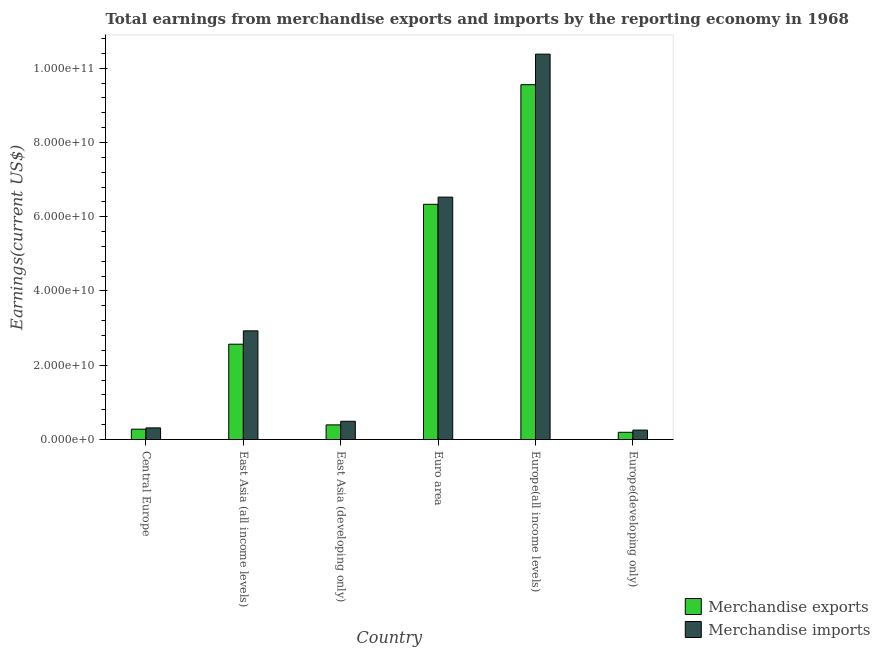How many different coloured bars are there?
Your answer should be compact. 2. Are the number of bars per tick equal to the number of legend labels?
Offer a terse response. Yes. Are the number of bars on each tick of the X-axis equal?
Your answer should be compact. Yes. How many bars are there on the 5th tick from the right?
Ensure brevity in your answer.  2. What is the label of the 1st group of bars from the left?
Ensure brevity in your answer.  Central Europe. What is the earnings from merchandise imports in Europe(all income levels)?
Provide a succinct answer. 1.04e+11. Across all countries, what is the maximum earnings from merchandise exports?
Provide a succinct answer. 9.56e+1. Across all countries, what is the minimum earnings from merchandise imports?
Offer a terse response. 2.54e+09. In which country was the earnings from merchandise imports maximum?
Provide a short and direct response. Europe(all income levels). In which country was the earnings from merchandise imports minimum?
Your answer should be compact. Europe(developing only). What is the total earnings from merchandise exports in the graph?
Your response must be concise. 1.93e+11. What is the difference between the earnings from merchandise exports in Central Europe and that in Europe(all income levels)?
Offer a very short reply. -9.28e+1. What is the difference between the earnings from merchandise imports in East Asia (all income levels) and the earnings from merchandise exports in Central Europe?
Make the answer very short. 2.65e+1. What is the average earnings from merchandise imports per country?
Your answer should be compact. 3.48e+1. What is the difference between the earnings from merchandise exports and earnings from merchandise imports in Central Europe?
Your response must be concise. -3.47e+08. In how many countries, is the earnings from merchandise imports greater than 4000000000 US$?
Provide a succinct answer. 4. What is the ratio of the earnings from merchandise imports in Central Europe to that in Europe(developing only)?
Your answer should be very brief. 1.23. Is the difference between the earnings from merchandise imports in Europe(all income levels) and Europe(developing only) greater than the difference between the earnings from merchandise exports in Europe(all income levels) and Europe(developing only)?
Your answer should be compact. Yes. What is the difference between the highest and the second highest earnings from merchandise exports?
Make the answer very short. 3.22e+1. What is the difference between the highest and the lowest earnings from merchandise exports?
Make the answer very short. 9.36e+1. In how many countries, is the earnings from merchandise imports greater than the average earnings from merchandise imports taken over all countries?
Make the answer very short. 2. Are all the bars in the graph horizontal?
Offer a terse response. No. How many countries are there in the graph?
Ensure brevity in your answer.  6. What is the difference between two consecutive major ticks on the Y-axis?
Offer a terse response. 2.00e+1. Are the values on the major ticks of Y-axis written in scientific E-notation?
Your answer should be very brief. Yes. Does the graph contain any zero values?
Offer a terse response. No. Does the graph contain grids?
Provide a short and direct response. No. Where does the legend appear in the graph?
Ensure brevity in your answer.  Bottom right. How many legend labels are there?
Keep it short and to the point. 2. How are the legend labels stacked?
Provide a succinct answer. Vertical. What is the title of the graph?
Your answer should be very brief. Total earnings from merchandise exports and imports by the reporting economy in 1968. What is the label or title of the Y-axis?
Give a very brief answer. Earnings(current US$). What is the Earnings(current US$) of Merchandise exports in Central Europe?
Your response must be concise. 2.79e+09. What is the Earnings(current US$) of Merchandise imports in Central Europe?
Keep it short and to the point. 3.13e+09. What is the Earnings(current US$) in Merchandise exports in East Asia (all income levels)?
Provide a succinct answer. 2.57e+1. What is the Earnings(current US$) of Merchandise imports in East Asia (all income levels)?
Give a very brief answer. 2.93e+1. What is the Earnings(current US$) of Merchandise exports in East Asia (developing only)?
Give a very brief answer. 3.94e+09. What is the Earnings(current US$) of Merchandise imports in East Asia (developing only)?
Ensure brevity in your answer.  4.91e+09. What is the Earnings(current US$) of Merchandise exports in Euro area?
Make the answer very short. 6.33e+1. What is the Earnings(current US$) in Merchandise imports in Euro area?
Your response must be concise. 6.53e+1. What is the Earnings(current US$) of Merchandise exports in Europe(all income levels)?
Your answer should be very brief. 9.56e+1. What is the Earnings(current US$) in Merchandise imports in Europe(all income levels)?
Give a very brief answer. 1.04e+11. What is the Earnings(current US$) of Merchandise exports in Europe(developing only)?
Give a very brief answer. 1.95e+09. What is the Earnings(current US$) of Merchandise imports in Europe(developing only)?
Make the answer very short. 2.54e+09. Across all countries, what is the maximum Earnings(current US$) of Merchandise exports?
Your response must be concise. 9.56e+1. Across all countries, what is the maximum Earnings(current US$) in Merchandise imports?
Make the answer very short. 1.04e+11. Across all countries, what is the minimum Earnings(current US$) of Merchandise exports?
Provide a succinct answer. 1.95e+09. Across all countries, what is the minimum Earnings(current US$) in Merchandise imports?
Provide a short and direct response. 2.54e+09. What is the total Earnings(current US$) of Merchandise exports in the graph?
Your answer should be compact. 1.93e+11. What is the total Earnings(current US$) in Merchandise imports in the graph?
Give a very brief answer. 2.09e+11. What is the difference between the Earnings(current US$) of Merchandise exports in Central Europe and that in East Asia (all income levels)?
Keep it short and to the point. -2.29e+1. What is the difference between the Earnings(current US$) in Merchandise imports in Central Europe and that in East Asia (all income levels)?
Make the answer very short. -2.61e+1. What is the difference between the Earnings(current US$) in Merchandise exports in Central Europe and that in East Asia (developing only)?
Provide a succinct answer. -1.16e+09. What is the difference between the Earnings(current US$) of Merchandise imports in Central Europe and that in East Asia (developing only)?
Provide a succinct answer. -1.78e+09. What is the difference between the Earnings(current US$) in Merchandise exports in Central Europe and that in Euro area?
Your answer should be very brief. -6.06e+1. What is the difference between the Earnings(current US$) in Merchandise imports in Central Europe and that in Euro area?
Give a very brief answer. -6.21e+1. What is the difference between the Earnings(current US$) of Merchandise exports in Central Europe and that in Europe(all income levels)?
Keep it short and to the point. -9.28e+1. What is the difference between the Earnings(current US$) of Merchandise imports in Central Europe and that in Europe(all income levels)?
Provide a short and direct response. -1.01e+11. What is the difference between the Earnings(current US$) of Merchandise exports in Central Europe and that in Europe(developing only)?
Your response must be concise. 8.38e+08. What is the difference between the Earnings(current US$) of Merchandise imports in Central Europe and that in Europe(developing only)?
Keep it short and to the point. 5.91e+08. What is the difference between the Earnings(current US$) of Merchandise exports in East Asia (all income levels) and that in East Asia (developing only)?
Make the answer very short. 2.17e+1. What is the difference between the Earnings(current US$) of Merchandise imports in East Asia (all income levels) and that in East Asia (developing only)?
Offer a very short reply. 2.44e+1. What is the difference between the Earnings(current US$) of Merchandise exports in East Asia (all income levels) and that in Euro area?
Provide a succinct answer. -3.77e+1. What is the difference between the Earnings(current US$) in Merchandise imports in East Asia (all income levels) and that in Euro area?
Give a very brief answer. -3.60e+1. What is the difference between the Earnings(current US$) of Merchandise exports in East Asia (all income levels) and that in Europe(all income levels)?
Your answer should be compact. -6.99e+1. What is the difference between the Earnings(current US$) in Merchandise imports in East Asia (all income levels) and that in Europe(all income levels)?
Ensure brevity in your answer.  -7.45e+1. What is the difference between the Earnings(current US$) of Merchandise exports in East Asia (all income levels) and that in Europe(developing only)?
Ensure brevity in your answer.  2.37e+1. What is the difference between the Earnings(current US$) of Merchandise imports in East Asia (all income levels) and that in Europe(developing only)?
Keep it short and to the point. 2.67e+1. What is the difference between the Earnings(current US$) of Merchandise exports in East Asia (developing only) and that in Euro area?
Make the answer very short. -5.94e+1. What is the difference between the Earnings(current US$) in Merchandise imports in East Asia (developing only) and that in Euro area?
Provide a succinct answer. -6.04e+1. What is the difference between the Earnings(current US$) of Merchandise exports in East Asia (developing only) and that in Europe(all income levels)?
Provide a short and direct response. -9.16e+1. What is the difference between the Earnings(current US$) in Merchandise imports in East Asia (developing only) and that in Europe(all income levels)?
Make the answer very short. -9.89e+1. What is the difference between the Earnings(current US$) of Merchandise exports in East Asia (developing only) and that in Europe(developing only)?
Offer a terse response. 1.99e+09. What is the difference between the Earnings(current US$) in Merchandise imports in East Asia (developing only) and that in Europe(developing only)?
Offer a terse response. 2.37e+09. What is the difference between the Earnings(current US$) in Merchandise exports in Euro area and that in Europe(all income levels)?
Your answer should be very brief. -3.22e+1. What is the difference between the Earnings(current US$) of Merchandise imports in Euro area and that in Europe(all income levels)?
Provide a short and direct response. -3.85e+1. What is the difference between the Earnings(current US$) in Merchandise exports in Euro area and that in Europe(developing only)?
Your answer should be compact. 6.14e+1. What is the difference between the Earnings(current US$) of Merchandise imports in Euro area and that in Europe(developing only)?
Keep it short and to the point. 6.27e+1. What is the difference between the Earnings(current US$) of Merchandise exports in Europe(all income levels) and that in Europe(developing only)?
Offer a very short reply. 9.36e+1. What is the difference between the Earnings(current US$) in Merchandise imports in Europe(all income levels) and that in Europe(developing only)?
Ensure brevity in your answer.  1.01e+11. What is the difference between the Earnings(current US$) in Merchandise exports in Central Europe and the Earnings(current US$) in Merchandise imports in East Asia (all income levels)?
Provide a short and direct response. -2.65e+1. What is the difference between the Earnings(current US$) of Merchandise exports in Central Europe and the Earnings(current US$) of Merchandise imports in East Asia (developing only)?
Give a very brief answer. -2.13e+09. What is the difference between the Earnings(current US$) in Merchandise exports in Central Europe and the Earnings(current US$) in Merchandise imports in Euro area?
Offer a very short reply. -6.25e+1. What is the difference between the Earnings(current US$) in Merchandise exports in Central Europe and the Earnings(current US$) in Merchandise imports in Europe(all income levels)?
Provide a succinct answer. -1.01e+11. What is the difference between the Earnings(current US$) of Merchandise exports in Central Europe and the Earnings(current US$) of Merchandise imports in Europe(developing only)?
Provide a short and direct response. 2.45e+08. What is the difference between the Earnings(current US$) in Merchandise exports in East Asia (all income levels) and the Earnings(current US$) in Merchandise imports in East Asia (developing only)?
Offer a terse response. 2.08e+1. What is the difference between the Earnings(current US$) in Merchandise exports in East Asia (all income levels) and the Earnings(current US$) in Merchandise imports in Euro area?
Keep it short and to the point. -3.96e+1. What is the difference between the Earnings(current US$) of Merchandise exports in East Asia (all income levels) and the Earnings(current US$) of Merchandise imports in Europe(all income levels)?
Make the answer very short. -7.81e+1. What is the difference between the Earnings(current US$) of Merchandise exports in East Asia (all income levels) and the Earnings(current US$) of Merchandise imports in Europe(developing only)?
Ensure brevity in your answer.  2.31e+1. What is the difference between the Earnings(current US$) of Merchandise exports in East Asia (developing only) and the Earnings(current US$) of Merchandise imports in Euro area?
Your answer should be very brief. -6.13e+1. What is the difference between the Earnings(current US$) of Merchandise exports in East Asia (developing only) and the Earnings(current US$) of Merchandise imports in Europe(all income levels)?
Your answer should be compact. -9.98e+1. What is the difference between the Earnings(current US$) in Merchandise exports in East Asia (developing only) and the Earnings(current US$) in Merchandise imports in Europe(developing only)?
Ensure brevity in your answer.  1.40e+09. What is the difference between the Earnings(current US$) of Merchandise exports in Euro area and the Earnings(current US$) of Merchandise imports in Europe(all income levels)?
Offer a very short reply. -4.04e+1. What is the difference between the Earnings(current US$) in Merchandise exports in Euro area and the Earnings(current US$) in Merchandise imports in Europe(developing only)?
Provide a short and direct response. 6.08e+1. What is the difference between the Earnings(current US$) of Merchandise exports in Europe(all income levels) and the Earnings(current US$) of Merchandise imports in Europe(developing only)?
Your response must be concise. 9.30e+1. What is the average Earnings(current US$) in Merchandise exports per country?
Offer a very short reply. 3.22e+1. What is the average Earnings(current US$) in Merchandise imports per country?
Provide a succinct answer. 3.48e+1. What is the difference between the Earnings(current US$) of Merchandise exports and Earnings(current US$) of Merchandise imports in Central Europe?
Keep it short and to the point. -3.47e+08. What is the difference between the Earnings(current US$) in Merchandise exports and Earnings(current US$) in Merchandise imports in East Asia (all income levels)?
Your response must be concise. -3.59e+09. What is the difference between the Earnings(current US$) of Merchandise exports and Earnings(current US$) of Merchandise imports in East Asia (developing only)?
Your answer should be compact. -9.73e+08. What is the difference between the Earnings(current US$) of Merchandise exports and Earnings(current US$) of Merchandise imports in Euro area?
Offer a very short reply. -1.93e+09. What is the difference between the Earnings(current US$) in Merchandise exports and Earnings(current US$) in Merchandise imports in Europe(all income levels)?
Make the answer very short. -8.22e+09. What is the difference between the Earnings(current US$) in Merchandise exports and Earnings(current US$) in Merchandise imports in Europe(developing only)?
Your answer should be very brief. -5.94e+08. What is the ratio of the Earnings(current US$) of Merchandise exports in Central Europe to that in East Asia (all income levels)?
Your response must be concise. 0.11. What is the ratio of the Earnings(current US$) in Merchandise imports in Central Europe to that in East Asia (all income levels)?
Your answer should be very brief. 0.11. What is the ratio of the Earnings(current US$) in Merchandise exports in Central Europe to that in East Asia (developing only)?
Your response must be concise. 0.71. What is the ratio of the Earnings(current US$) in Merchandise imports in Central Europe to that in East Asia (developing only)?
Give a very brief answer. 0.64. What is the ratio of the Earnings(current US$) of Merchandise exports in Central Europe to that in Euro area?
Give a very brief answer. 0.04. What is the ratio of the Earnings(current US$) of Merchandise imports in Central Europe to that in Euro area?
Provide a short and direct response. 0.05. What is the ratio of the Earnings(current US$) of Merchandise exports in Central Europe to that in Europe(all income levels)?
Offer a very short reply. 0.03. What is the ratio of the Earnings(current US$) in Merchandise imports in Central Europe to that in Europe(all income levels)?
Give a very brief answer. 0.03. What is the ratio of the Earnings(current US$) of Merchandise exports in Central Europe to that in Europe(developing only)?
Offer a terse response. 1.43. What is the ratio of the Earnings(current US$) of Merchandise imports in Central Europe to that in Europe(developing only)?
Your answer should be compact. 1.23. What is the ratio of the Earnings(current US$) in Merchandise exports in East Asia (all income levels) to that in East Asia (developing only)?
Your answer should be compact. 6.51. What is the ratio of the Earnings(current US$) in Merchandise imports in East Asia (all income levels) to that in East Asia (developing only)?
Your answer should be very brief. 5.95. What is the ratio of the Earnings(current US$) of Merchandise exports in East Asia (all income levels) to that in Euro area?
Provide a succinct answer. 0.41. What is the ratio of the Earnings(current US$) in Merchandise imports in East Asia (all income levels) to that in Euro area?
Provide a short and direct response. 0.45. What is the ratio of the Earnings(current US$) in Merchandise exports in East Asia (all income levels) to that in Europe(all income levels)?
Your answer should be compact. 0.27. What is the ratio of the Earnings(current US$) in Merchandise imports in East Asia (all income levels) to that in Europe(all income levels)?
Provide a short and direct response. 0.28. What is the ratio of the Earnings(current US$) of Merchandise exports in East Asia (all income levels) to that in Europe(developing only)?
Ensure brevity in your answer.  13.19. What is the ratio of the Earnings(current US$) of Merchandise imports in East Asia (all income levels) to that in Europe(developing only)?
Ensure brevity in your answer.  11.52. What is the ratio of the Earnings(current US$) in Merchandise exports in East Asia (developing only) to that in Euro area?
Provide a succinct answer. 0.06. What is the ratio of the Earnings(current US$) in Merchandise imports in East Asia (developing only) to that in Euro area?
Make the answer very short. 0.08. What is the ratio of the Earnings(current US$) in Merchandise exports in East Asia (developing only) to that in Europe(all income levels)?
Give a very brief answer. 0.04. What is the ratio of the Earnings(current US$) of Merchandise imports in East Asia (developing only) to that in Europe(all income levels)?
Offer a terse response. 0.05. What is the ratio of the Earnings(current US$) of Merchandise exports in East Asia (developing only) to that in Europe(developing only)?
Your answer should be compact. 2.02. What is the ratio of the Earnings(current US$) of Merchandise imports in East Asia (developing only) to that in Europe(developing only)?
Make the answer very short. 1.93. What is the ratio of the Earnings(current US$) in Merchandise exports in Euro area to that in Europe(all income levels)?
Provide a short and direct response. 0.66. What is the ratio of the Earnings(current US$) of Merchandise imports in Euro area to that in Europe(all income levels)?
Your answer should be very brief. 0.63. What is the ratio of the Earnings(current US$) of Merchandise exports in Euro area to that in Europe(developing only)?
Your response must be concise. 32.54. What is the ratio of the Earnings(current US$) of Merchandise imports in Euro area to that in Europe(developing only)?
Your response must be concise. 25.69. What is the ratio of the Earnings(current US$) in Merchandise exports in Europe(all income levels) to that in Europe(developing only)?
Provide a short and direct response. 49.08. What is the ratio of the Earnings(current US$) in Merchandise imports in Europe(all income levels) to that in Europe(developing only)?
Offer a very short reply. 40.85. What is the difference between the highest and the second highest Earnings(current US$) of Merchandise exports?
Offer a very short reply. 3.22e+1. What is the difference between the highest and the second highest Earnings(current US$) in Merchandise imports?
Keep it short and to the point. 3.85e+1. What is the difference between the highest and the lowest Earnings(current US$) in Merchandise exports?
Offer a terse response. 9.36e+1. What is the difference between the highest and the lowest Earnings(current US$) of Merchandise imports?
Offer a terse response. 1.01e+11. 